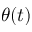<formula> <loc_0><loc_0><loc_500><loc_500>\theta ( t )</formula> 